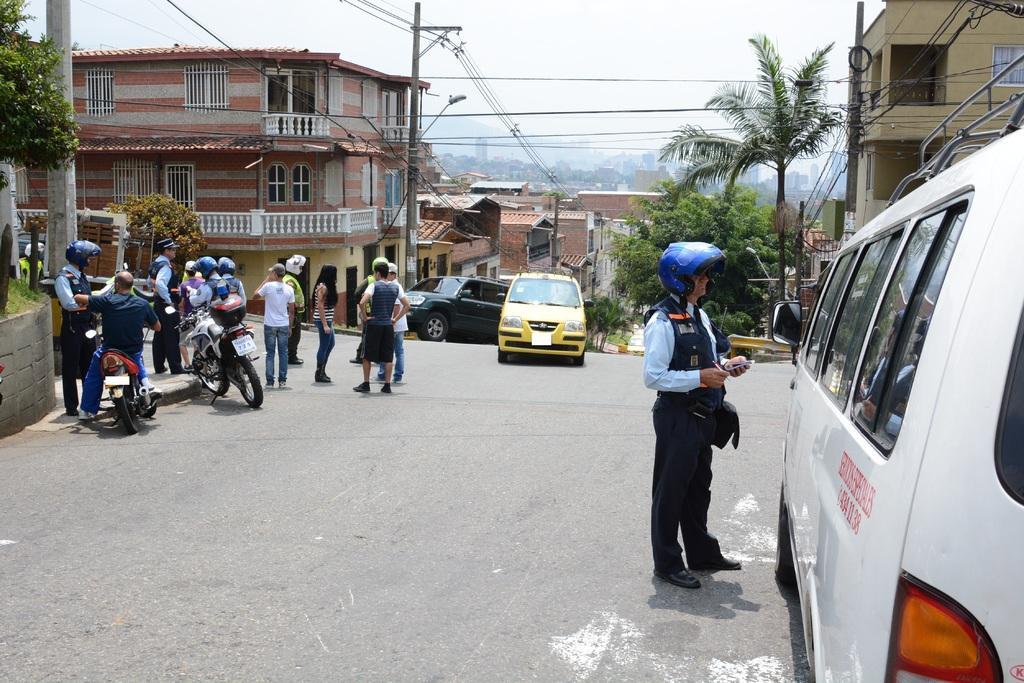How would you summarize this image in a sentence or two? In this image there is the sky, there are buildings, there is a building truncated towards the right of the image, there are trees, there is a tree truncated towards the left of the image, there is road truncated towards the bottom of the image, there are persons on the road, there are persons holding objects, there are vehicles on the road, there is a vehicle truncated towards the right of the image, there are poles truncated towards the top of the image, there are wires truncated, there is a vehicle truncated towards the right of the image, there is an object truncated towards the left of the image. 